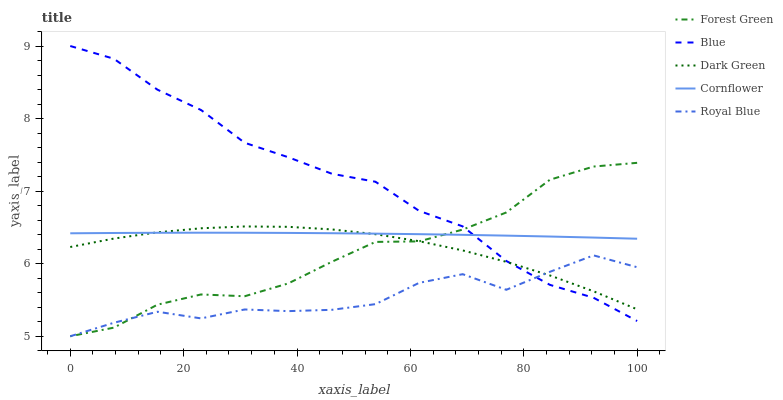Does Royal Blue have the minimum area under the curve?
Answer yes or no. Yes. Does Blue have the maximum area under the curve?
Answer yes or no. Yes. Does Cornflower have the minimum area under the curve?
Answer yes or no. No. Does Cornflower have the maximum area under the curve?
Answer yes or no. No. Is Cornflower the smoothest?
Answer yes or no. Yes. Is Royal Blue the roughest?
Answer yes or no. Yes. Is Forest Green the smoothest?
Answer yes or no. No. Is Forest Green the roughest?
Answer yes or no. No. Does Forest Green have the lowest value?
Answer yes or no. Yes. Does Cornflower have the lowest value?
Answer yes or no. No. Does Blue have the highest value?
Answer yes or no. Yes. Does Cornflower have the highest value?
Answer yes or no. No. Is Royal Blue less than Cornflower?
Answer yes or no. Yes. Is Cornflower greater than Royal Blue?
Answer yes or no. Yes. Does Forest Green intersect Blue?
Answer yes or no. Yes. Is Forest Green less than Blue?
Answer yes or no. No. Is Forest Green greater than Blue?
Answer yes or no. No. Does Royal Blue intersect Cornflower?
Answer yes or no. No. 